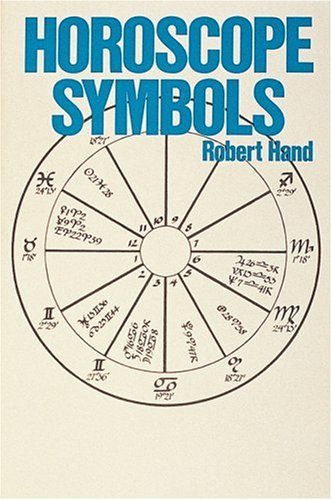What is the title of this book? The title of the book is 'Horoscope Symbols'. It explores various astrological symbols and their meanings, offering insights into this intriguing field. 